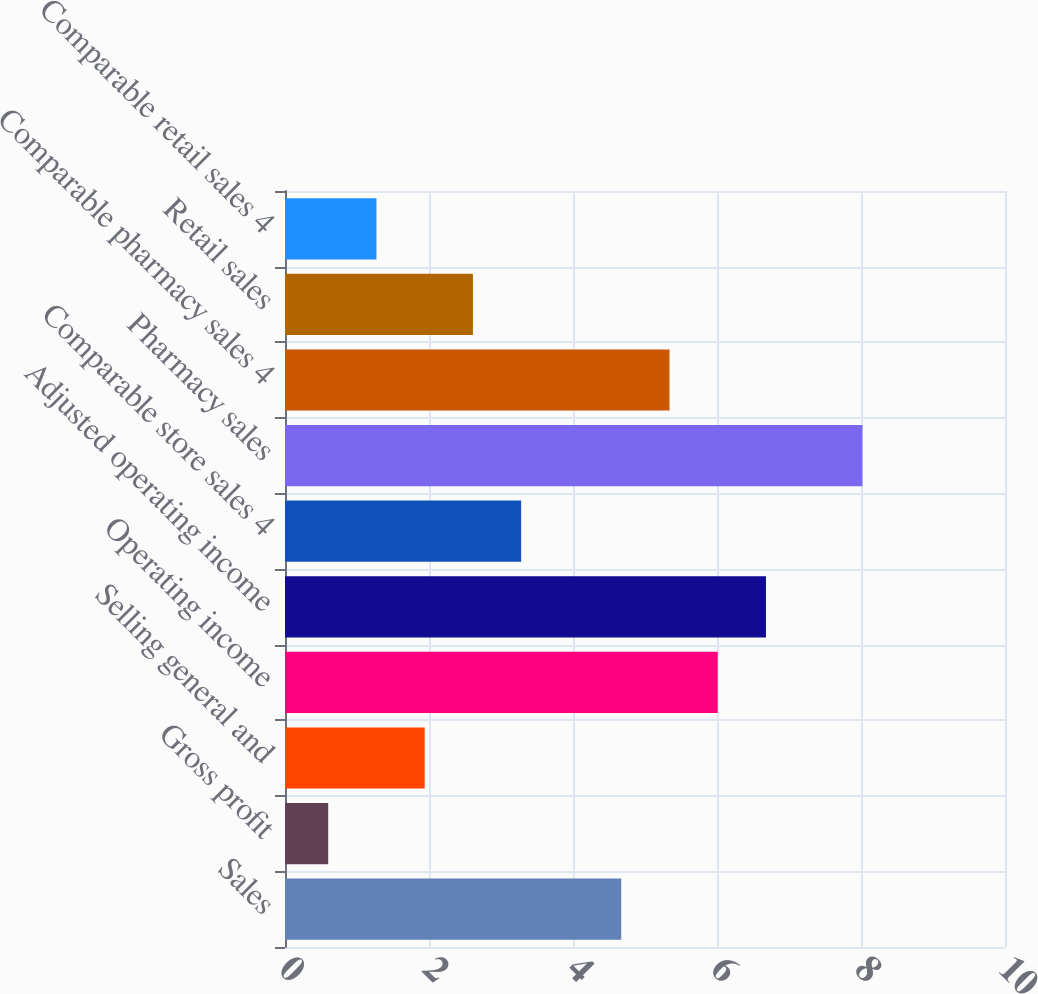Convert chart. <chart><loc_0><loc_0><loc_500><loc_500><bar_chart><fcel>Sales<fcel>Gross profit<fcel>Selling general and<fcel>Operating income<fcel>Adjusted operating income<fcel>Comparable store sales 4<fcel>Pharmacy sales<fcel>Comparable pharmacy sales 4<fcel>Retail sales<fcel>Comparable retail sales 4<nl><fcel>4.67<fcel>0.6<fcel>1.94<fcel>6.01<fcel>6.68<fcel>3.28<fcel>8.02<fcel>5.34<fcel>2.61<fcel>1.27<nl></chart> 